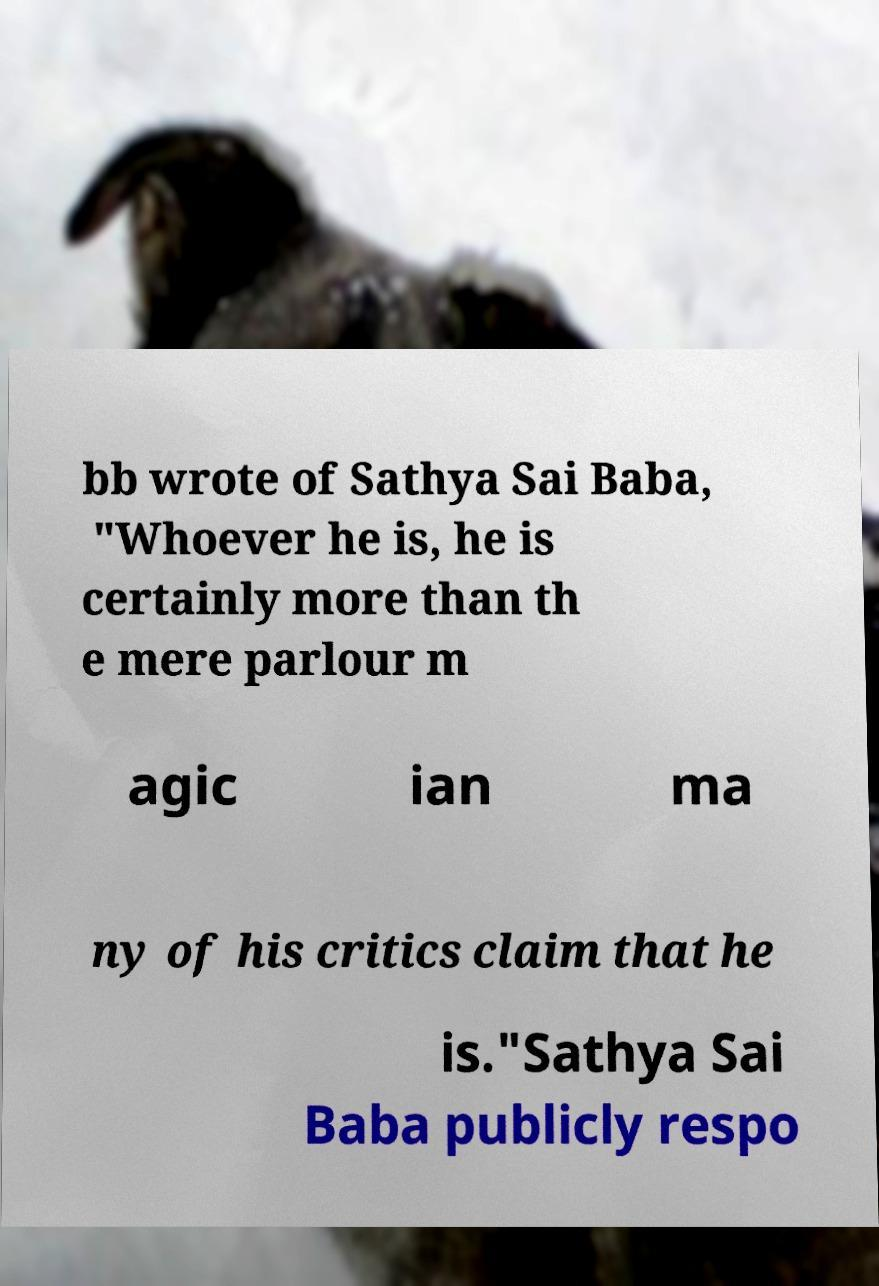What messages or text are displayed in this image? I need them in a readable, typed format. bb wrote of Sathya Sai Baba, "Whoever he is, he is certainly more than th e mere parlour m agic ian ma ny of his critics claim that he is."Sathya Sai Baba publicly respo 